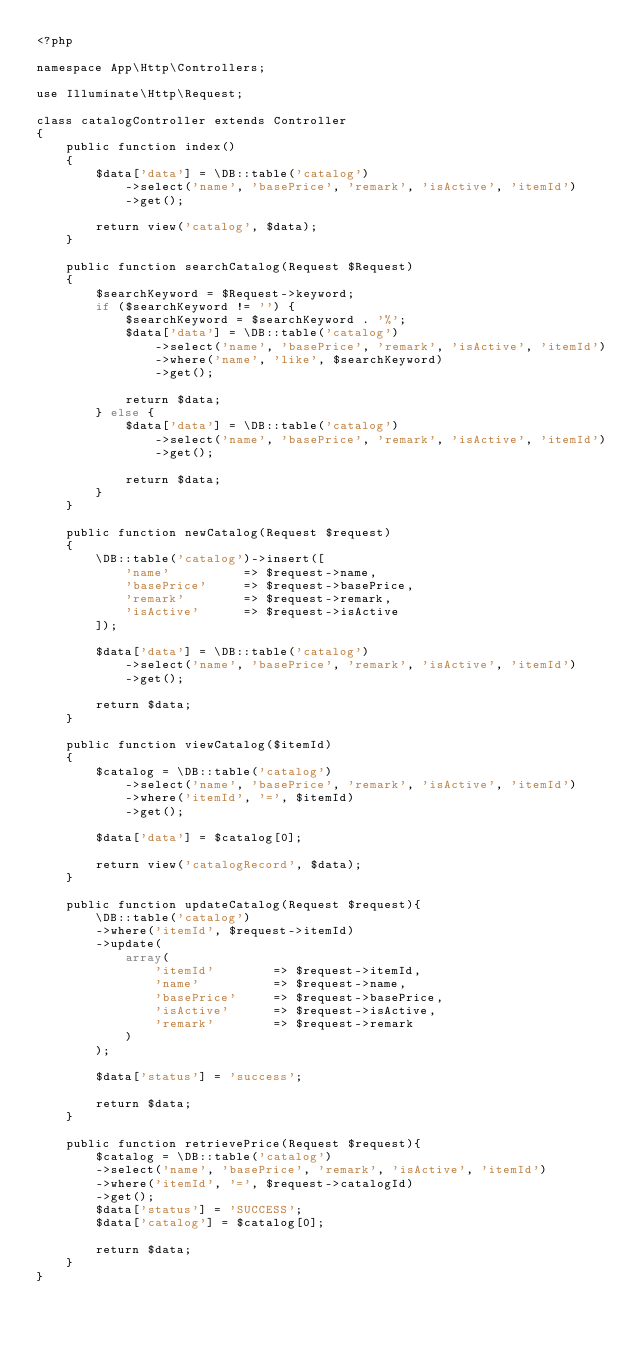Convert code to text. <code><loc_0><loc_0><loc_500><loc_500><_PHP_><?php

namespace App\Http\Controllers;

use Illuminate\Http\Request;

class catalogController extends Controller
{
    public function index()
    {
        $data['data'] = \DB::table('catalog')
            ->select('name', 'basePrice', 'remark', 'isActive', 'itemId')
            ->get();

        return view('catalog', $data);
    }

    public function searchCatalog(Request $Request)
    {
        $searchKeyword = $Request->keyword;
        if ($searchKeyword != '') {
            $searchKeyword = $searchKeyword . '%';
            $data['data'] = \DB::table('catalog')
                ->select('name', 'basePrice', 'remark', 'isActive', 'itemId')
                ->where('name', 'like', $searchKeyword)
                ->get();

            return $data;
        } else {
            $data['data'] = \DB::table('catalog')
                ->select('name', 'basePrice', 'remark', 'isActive', 'itemId')
                ->get();

            return $data;
        }
    }

    public function newCatalog(Request $request)
    {
        \DB::table('catalog')->insert([
            'name'          => $request->name,
            'basePrice'     => $request->basePrice,
            'remark'        => $request->remark,
            'isActive'      => $request->isActive
        ]);

        $data['data'] = \DB::table('catalog')
            ->select('name', 'basePrice', 'remark', 'isActive', 'itemId')
            ->get();

        return $data;
    }

    public function viewCatalog($itemId)
    {
        $catalog = \DB::table('catalog')
            ->select('name', 'basePrice', 'remark', 'isActive', 'itemId')
            ->where('itemId', '=', $itemId)
            ->get();
        
        $data['data'] = $catalog[0];

        return view('catalogRecord', $data);
    }

    public function updateCatalog(Request $request){
        \DB::table('catalog')
        ->where('itemId', $request->itemId)
        ->update(
            array(
                'itemId'        => $request->itemId,
                'name'          => $request->name,
                'basePrice'     => $request->basePrice,
                'isActive'      => $request->isActive,
                'remark'        => $request->remark
            )
        );

        $data['status'] = 'success';

        return $data;
    }

    public function retrievePrice(Request $request){
        $catalog = \DB::table('catalog')
        ->select('name', 'basePrice', 'remark', 'isActive', 'itemId')
        ->where('itemId', '=', $request->catalogId)
        ->get();
        $data['status'] = 'SUCCESS';
        $data['catalog'] = $catalog[0];

        return $data;
    }
}
</code> 